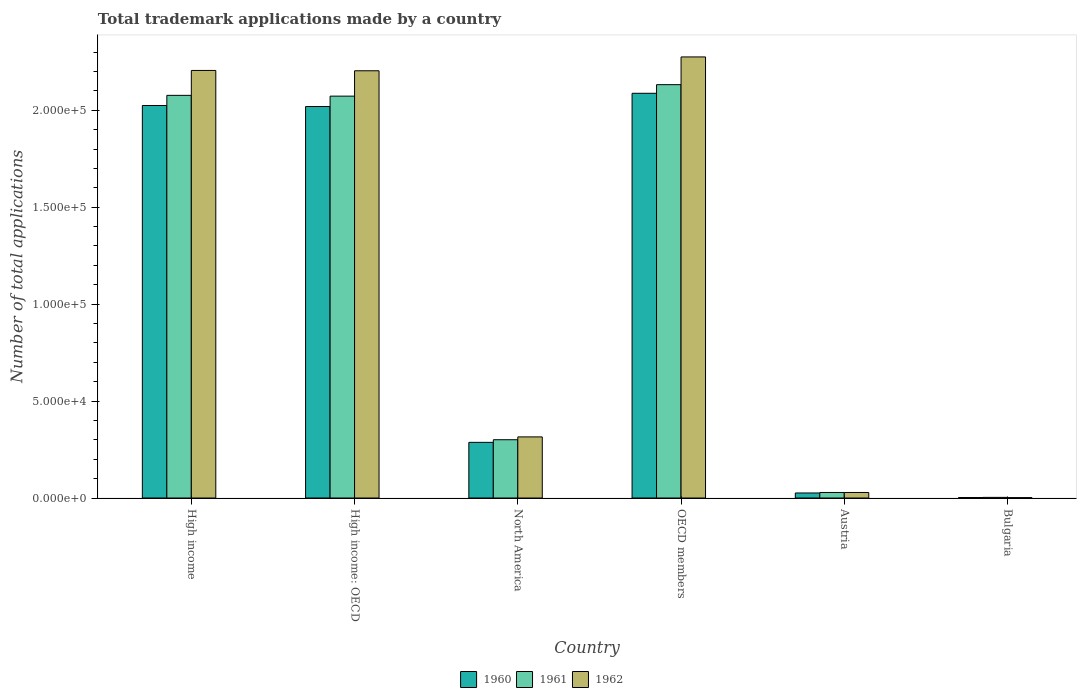How many different coloured bars are there?
Ensure brevity in your answer.  3. How many groups of bars are there?
Your answer should be very brief. 6. Are the number of bars per tick equal to the number of legend labels?
Give a very brief answer. Yes. Are the number of bars on each tick of the X-axis equal?
Your response must be concise. Yes. How many bars are there on the 5th tick from the right?
Provide a short and direct response. 3. What is the label of the 4th group of bars from the left?
Provide a short and direct response. OECD members. In how many cases, is the number of bars for a given country not equal to the number of legend labels?
Keep it short and to the point. 0. What is the number of applications made by in 1960 in OECD members?
Provide a short and direct response. 2.09e+05. Across all countries, what is the maximum number of applications made by in 1961?
Your answer should be compact. 2.13e+05. Across all countries, what is the minimum number of applications made by in 1962?
Provide a succinct answer. 195. In which country was the number of applications made by in 1961 maximum?
Offer a very short reply. OECD members. In which country was the number of applications made by in 1961 minimum?
Provide a succinct answer. Bulgaria. What is the total number of applications made by in 1960 in the graph?
Offer a terse response. 6.45e+05. What is the difference between the number of applications made by in 1962 in High income and that in High income: OECD?
Your answer should be very brief. 170. What is the difference between the number of applications made by in 1962 in Austria and the number of applications made by in 1961 in High income?
Your answer should be very brief. -2.05e+05. What is the average number of applications made by in 1962 per country?
Provide a short and direct response. 1.17e+05. What is the difference between the number of applications made by of/in 1962 and number of applications made by of/in 1961 in Austria?
Provide a succinct answer. -3. In how many countries, is the number of applications made by in 1960 greater than 200000?
Your answer should be very brief. 3. What is the ratio of the number of applications made by in 1960 in High income: OECD to that in OECD members?
Provide a short and direct response. 0.97. Is the number of applications made by in 1960 in High income less than that in North America?
Provide a short and direct response. No. Is the difference between the number of applications made by in 1962 in High income and North America greater than the difference between the number of applications made by in 1961 in High income and North America?
Keep it short and to the point. Yes. What is the difference between the highest and the second highest number of applications made by in 1961?
Offer a terse response. -401. What is the difference between the highest and the lowest number of applications made by in 1960?
Offer a very short reply. 2.09e+05. In how many countries, is the number of applications made by in 1960 greater than the average number of applications made by in 1960 taken over all countries?
Give a very brief answer. 3. Is the sum of the number of applications made by in 1962 in Bulgaria and High income greater than the maximum number of applications made by in 1960 across all countries?
Ensure brevity in your answer.  Yes. Is it the case that in every country, the sum of the number of applications made by in 1962 and number of applications made by in 1960 is greater than the number of applications made by in 1961?
Make the answer very short. Yes. How many bars are there?
Your answer should be compact. 18. Are all the bars in the graph horizontal?
Offer a terse response. No. What is the difference between two consecutive major ticks on the Y-axis?
Make the answer very short. 5.00e+04. Are the values on the major ticks of Y-axis written in scientific E-notation?
Give a very brief answer. Yes. Does the graph contain grids?
Provide a short and direct response. No. How are the legend labels stacked?
Your response must be concise. Horizontal. What is the title of the graph?
Offer a very short reply. Total trademark applications made by a country. What is the label or title of the Y-axis?
Give a very brief answer. Number of total applications. What is the Number of total applications in 1960 in High income?
Offer a very short reply. 2.02e+05. What is the Number of total applications in 1961 in High income?
Your answer should be very brief. 2.08e+05. What is the Number of total applications in 1962 in High income?
Provide a short and direct response. 2.21e+05. What is the Number of total applications of 1960 in High income: OECD?
Your answer should be very brief. 2.02e+05. What is the Number of total applications of 1961 in High income: OECD?
Offer a very short reply. 2.07e+05. What is the Number of total applications of 1962 in High income: OECD?
Ensure brevity in your answer.  2.20e+05. What is the Number of total applications in 1960 in North America?
Your answer should be very brief. 2.87e+04. What is the Number of total applications of 1961 in North America?
Provide a succinct answer. 3.01e+04. What is the Number of total applications in 1962 in North America?
Offer a very short reply. 3.15e+04. What is the Number of total applications in 1960 in OECD members?
Your answer should be very brief. 2.09e+05. What is the Number of total applications in 1961 in OECD members?
Give a very brief answer. 2.13e+05. What is the Number of total applications of 1962 in OECD members?
Your response must be concise. 2.28e+05. What is the Number of total applications in 1960 in Austria?
Your answer should be very brief. 2596. What is the Number of total applications of 1961 in Austria?
Provide a short and direct response. 2852. What is the Number of total applications of 1962 in Austria?
Make the answer very short. 2849. What is the Number of total applications of 1960 in Bulgaria?
Make the answer very short. 250. What is the Number of total applications in 1961 in Bulgaria?
Provide a short and direct response. 318. What is the Number of total applications in 1962 in Bulgaria?
Provide a short and direct response. 195. Across all countries, what is the maximum Number of total applications of 1960?
Your response must be concise. 2.09e+05. Across all countries, what is the maximum Number of total applications in 1961?
Your response must be concise. 2.13e+05. Across all countries, what is the maximum Number of total applications in 1962?
Give a very brief answer. 2.28e+05. Across all countries, what is the minimum Number of total applications in 1960?
Ensure brevity in your answer.  250. Across all countries, what is the minimum Number of total applications of 1961?
Your answer should be compact. 318. Across all countries, what is the minimum Number of total applications of 1962?
Make the answer very short. 195. What is the total Number of total applications in 1960 in the graph?
Your response must be concise. 6.45e+05. What is the total Number of total applications in 1961 in the graph?
Your answer should be very brief. 6.61e+05. What is the total Number of total applications in 1962 in the graph?
Provide a short and direct response. 7.03e+05. What is the difference between the Number of total applications in 1960 in High income and that in High income: OECD?
Provide a short and direct response. 540. What is the difference between the Number of total applications in 1961 in High income and that in High income: OECD?
Your answer should be compact. 401. What is the difference between the Number of total applications of 1962 in High income and that in High income: OECD?
Provide a succinct answer. 170. What is the difference between the Number of total applications in 1960 in High income and that in North America?
Ensure brevity in your answer.  1.74e+05. What is the difference between the Number of total applications in 1961 in High income and that in North America?
Give a very brief answer. 1.78e+05. What is the difference between the Number of total applications of 1962 in High income and that in North America?
Your response must be concise. 1.89e+05. What is the difference between the Number of total applications in 1960 in High income and that in OECD members?
Ensure brevity in your answer.  -6293. What is the difference between the Number of total applications of 1961 in High income and that in OECD members?
Your answer should be compact. -5516. What is the difference between the Number of total applications of 1962 in High income and that in OECD members?
Your answer should be compact. -6969. What is the difference between the Number of total applications of 1960 in High income and that in Austria?
Offer a very short reply. 2.00e+05. What is the difference between the Number of total applications of 1961 in High income and that in Austria?
Provide a short and direct response. 2.05e+05. What is the difference between the Number of total applications in 1962 in High income and that in Austria?
Make the answer very short. 2.18e+05. What is the difference between the Number of total applications of 1960 in High income and that in Bulgaria?
Offer a terse response. 2.02e+05. What is the difference between the Number of total applications of 1961 in High income and that in Bulgaria?
Provide a succinct answer. 2.07e+05. What is the difference between the Number of total applications of 1962 in High income and that in Bulgaria?
Make the answer very short. 2.20e+05. What is the difference between the Number of total applications of 1960 in High income: OECD and that in North America?
Your response must be concise. 1.73e+05. What is the difference between the Number of total applications of 1961 in High income: OECD and that in North America?
Your answer should be very brief. 1.77e+05. What is the difference between the Number of total applications in 1962 in High income: OECD and that in North America?
Provide a succinct answer. 1.89e+05. What is the difference between the Number of total applications of 1960 in High income: OECD and that in OECD members?
Offer a very short reply. -6833. What is the difference between the Number of total applications in 1961 in High income: OECD and that in OECD members?
Your answer should be compact. -5917. What is the difference between the Number of total applications of 1962 in High income: OECD and that in OECD members?
Your response must be concise. -7139. What is the difference between the Number of total applications in 1960 in High income: OECD and that in Austria?
Your answer should be compact. 1.99e+05. What is the difference between the Number of total applications of 1961 in High income: OECD and that in Austria?
Keep it short and to the point. 2.04e+05. What is the difference between the Number of total applications of 1962 in High income: OECD and that in Austria?
Your answer should be compact. 2.18e+05. What is the difference between the Number of total applications in 1960 in High income: OECD and that in Bulgaria?
Provide a short and direct response. 2.02e+05. What is the difference between the Number of total applications in 1961 in High income: OECD and that in Bulgaria?
Ensure brevity in your answer.  2.07e+05. What is the difference between the Number of total applications of 1962 in High income: OECD and that in Bulgaria?
Your answer should be compact. 2.20e+05. What is the difference between the Number of total applications of 1960 in North America and that in OECD members?
Make the answer very short. -1.80e+05. What is the difference between the Number of total applications of 1961 in North America and that in OECD members?
Provide a succinct answer. -1.83e+05. What is the difference between the Number of total applications of 1962 in North America and that in OECD members?
Keep it short and to the point. -1.96e+05. What is the difference between the Number of total applications of 1960 in North America and that in Austria?
Your answer should be compact. 2.61e+04. What is the difference between the Number of total applications in 1961 in North America and that in Austria?
Offer a very short reply. 2.72e+04. What is the difference between the Number of total applications of 1962 in North America and that in Austria?
Your answer should be compact. 2.87e+04. What is the difference between the Number of total applications in 1960 in North America and that in Bulgaria?
Offer a very short reply. 2.85e+04. What is the difference between the Number of total applications of 1961 in North America and that in Bulgaria?
Your response must be concise. 2.97e+04. What is the difference between the Number of total applications in 1962 in North America and that in Bulgaria?
Provide a succinct answer. 3.13e+04. What is the difference between the Number of total applications of 1960 in OECD members and that in Austria?
Offer a very short reply. 2.06e+05. What is the difference between the Number of total applications of 1961 in OECD members and that in Austria?
Your answer should be very brief. 2.10e+05. What is the difference between the Number of total applications in 1962 in OECD members and that in Austria?
Offer a very short reply. 2.25e+05. What is the difference between the Number of total applications of 1960 in OECD members and that in Bulgaria?
Offer a terse response. 2.09e+05. What is the difference between the Number of total applications in 1961 in OECD members and that in Bulgaria?
Keep it short and to the point. 2.13e+05. What is the difference between the Number of total applications in 1962 in OECD members and that in Bulgaria?
Give a very brief answer. 2.27e+05. What is the difference between the Number of total applications of 1960 in Austria and that in Bulgaria?
Offer a very short reply. 2346. What is the difference between the Number of total applications in 1961 in Austria and that in Bulgaria?
Offer a terse response. 2534. What is the difference between the Number of total applications in 1962 in Austria and that in Bulgaria?
Keep it short and to the point. 2654. What is the difference between the Number of total applications in 1960 in High income and the Number of total applications in 1961 in High income: OECD?
Your answer should be compact. -4828. What is the difference between the Number of total applications of 1960 in High income and the Number of total applications of 1962 in High income: OECD?
Your answer should be compact. -1.79e+04. What is the difference between the Number of total applications of 1961 in High income and the Number of total applications of 1962 in High income: OECD?
Your response must be concise. -1.27e+04. What is the difference between the Number of total applications of 1960 in High income and the Number of total applications of 1961 in North America?
Provide a succinct answer. 1.72e+05. What is the difference between the Number of total applications in 1960 in High income and the Number of total applications in 1962 in North America?
Offer a terse response. 1.71e+05. What is the difference between the Number of total applications of 1961 in High income and the Number of total applications of 1962 in North America?
Give a very brief answer. 1.76e+05. What is the difference between the Number of total applications of 1960 in High income and the Number of total applications of 1961 in OECD members?
Offer a very short reply. -1.07e+04. What is the difference between the Number of total applications in 1960 in High income and the Number of total applications in 1962 in OECD members?
Ensure brevity in your answer.  -2.51e+04. What is the difference between the Number of total applications in 1961 in High income and the Number of total applications in 1962 in OECD members?
Your response must be concise. -1.98e+04. What is the difference between the Number of total applications of 1960 in High income and the Number of total applications of 1961 in Austria?
Make the answer very short. 2.00e+05. What is the difference between the Number of total applications of 1960 in High income and the Number of total applications of 1962 in Austria?
Provide a succinct answer. 2.00e+05. What is the difference between the Number of total applications in 1961 in High income and the Number of total applications in 1962 in Austria?
Provide a succinct answer. 2.05e+05. What is the difference between the Number of total applications in 1960 in High income and the Number of total applications in 1961 in Bulgaria?
Give a very brief answer. 2.02e+05. What is the difference between the Number of total applications of 1960 in High income and the Number of total applications of 1962 in Bulgaria?
Offer a very short reply. 2.02e+05. What is the difference between the Number of total applications of 1961 in High income and the Number of total applications of 1962 in Bulgaria?
Give a very brief answer. 2.08e+05. What is the difference between the Number of total applications of 1960 in High income: OECD and the Number of total applications of 1961 in North America?
Your answer should be compact. 1.72e+05. What is the difference between the Number of total applications in 1960 in High income: OECD and the Number of total applications in 1962 in North America?
Offer a very short reply. 1.70e+05. What is the difference between the Number of total applications in 1961 in High income: OECD and the Number of total applications in 1962 in North America?
Provide a succinct answer. 1.76e+05. What is the difference between the Number of total applications of 1960 in High income: OECD and the Number of total applications of 1961 in OECD members?
Give a very brief answer. -1.13e+04. What is the difference between the Number of total applications of 1960 in High income: OECD and the Number of total applications of 1962 in OECD members?
Your answer should be compact. -2.56e+04. What is the difference between the Number of total applications in 1961 in High income: OECD and the Number of total applications in 1962 in OECD members?
Provide a succinct answer. -2.02e+04. What is the difference between the Number of total applications in 1960 in High income: OECD and the Number of total applications in 1961 in Austria?
Keep it short and to the point. 1.99e+05. What is the difference between the Number of total applications of 1960 in High income: OECD and the Number of total applications of 1962 in Austria?
Your answer should be compact. 1.99e+05. What is the difference between the Number of total applications in 1961 in High income: OECD and the Number of total applications in 1962 in Austria?
Your answer should be very brief. 2.04e+05. What is the difference between the Number of total applications in 1960 in High income: OECD and the Number of total applications in 1961 in Bulgaria?
Ensure brevity in your answer.  2.02e+05. What is the difference between the Number of total applications in 1960 in High income: OECD and the Number of total applications in 1962 in Bulgaria?
Provide a short and direct response. 2.02e+05. What is the difference between the Number of total applications of 1961 in High income: OECD and the Number of total applications of 1962 in Bulgaria?
Your answer should be compact. 2.07e+05. What is the difference between the Number of total applications of 1960 in North America and the Number of total applications of 1961 in OECD members?
Your response must be concise. -1.85e+05. What is the difference between the Number of total applications of 1960 in North America and the Number of total applications of 1962 in OECD members?
Ensure brevity in your answer.  -1.99e+05. What is the difference between the Number of total applications of 1961 in North America and the Number of total applications of 1962 in OECD members?
Offer a terse response. -1.97e+05. What is the difference between the Number of total applications of 1960 in North America and the Number of total applications of 1961 in Austria?
Provide a succinct answer. 2.59e+04. What is the difference between the Number of total applications in 1960 in North America and the Number of total applications in 1962 in Austria?
Ensure brevity in your answer.  2.59e+04. What is the difference between the Number of total applications in 1961 in North America and the Number of total applications in 1962 in Austria?
Your answer should be very brief. 2.72e+04. What is the difference between the Number of total applications of 1960 in North America and the Number of total applications of 1961 in Bulgaria?
Your response must be concise. 2.84e+04. What is the difference between the Number of total applications of 1960 in North America and the Number of total applications of 1962 in Bulgaria?
Provide a succinct answer. 2.85e+04. What is the difference between the Number of total applications of 1961 in North America and the Number of total applications of 1962 in Bulgaria?
Provide a short and direct response. 2.99e+04. What is the difference between the Number of total applications of 1960 in OECD members and the Number of total applications of 1961 in Austria?
Make the answer very short. 2.06e+05. What is the difference between the Number of total applications in 1960 in OECD members and the Number of total applications in 1962 in Austria?
Your answer should be very brief. 2.06e+05. What is the difference between the Number of total applications of 1961 in OECD members and the Number of total applications of 1962 in Austria?
Provide a short and direct response. 2.10e+05. What is the difference between the Number of total applications of 1960 in OECD members and the Number of total applications of 1961 in Bulgaria?
Ensure brevity in your answer.  2.08e+05. What is the difference between the Number of total applications of 1960 in OECD members and the Number of total applications of 1962 in Bulgaria?
Ensure brevity in your answer.  2.09e+05. What is the difference between the Number of total applications in 1961 in OECD members and the Number of total applications in 1962 in Bulgaria?
Ensure brevity in your answer.  2.13e+05. What is the difference between the Number of total applications of 1960 in Austria and the Number of total applications of 1961 in Bulgaria?
Provide a succinct answer. 2278. What is the difference between the Number of total applications of 1960 in Austria and the Number of total applications of 1962 in Bulgaria?
Your answer should be very brief. 2401. What is the difference between the Number of total applications of 1961 in Austria and the Number of total applications of 1962 in Bulgaria?
Make the answer very short. 2657. What is the average Number of total applications in 1960 per country?
Ensure brevity in your answer.  1.07e+05. What is the average Number of total applications in 1961 per country?
Give a very brief answer. 1.10e+05. What is the average Number of total applications of 1962 per country?
Provide a succinct answer. 1.17e+05. What is the difference between the Number of total applications of 1960 and Number of total applications of 1961 in High income?
Offer a very short reply. -5229. What is the difference between the Number of total applications in 1960 and Number of total applications in 1962 in High income?
Give a very brief answer. -1.81e+04. What is the difference between the Number of total applications in 1961 and Number of total applications in 1962 in High income?
Keep it short and to the point. -1.29e+04. What is the difference between the Number of total applications in 1960 and Number of total applications in 1961 in High income: OECD?
Offer a very short reply. -5368. What is the difference between the Number of total applications in 1960 and Number of total applications in 1962 in High income: OECD?
Ensure brevity in your answer.  -1.85e+04. What is the difference between the Number of total applications in 1961 and Number of total applications in 1962 in High income: OECD?
Your response must be concise. -1.31e+04. What is the difference between the Number of total applications in 1960 and Number of total applications in 1961 in North America?
Keep it short and to the point. -1355. What is the difference between the Number of total applications in 1960 and Number of total applications in 1962 in North America?
Your response must be concise. -2817. What is the difference between the Number of total applications of 1961 and Number of total applications of 1962 in North America?
Offer a terse response. -1462. What is the difference between the Number of total applications of 1960 and Number of total applications of 1961 in OECD members?
Ensure brevity in your answer.  -4452. What is the difference between the Number of total applications in 1960 and Number of total applications in 1962 in OECD members?
Offer a very short reply. -1.88e+04. What is the difference between the Number of total applications of 1961 and Number of total applications of 1962 in OECD members?
Provide a succinct answer. -1.43e+04. What is the difference between the Number of total applications in 1960 and Number of total applications in 1961 in Austria?
Provide a short and direct response. -256. What is the difference between the Number of total applications of 1960 and Number of total applications of 1962 in Austria?
Ensure brevity in your answer.  -253. What is the difference between the Number of total applications of 1960 and Number of total applications of 1961 in Bulgaria?
Make the answer very short. -68. What is the difference between the Number of total applications in 1961 and Number of total applications in 1962 in Bulgaria?
Make the answer very short. 123. What is the ratio of the Number of total applications of 1960 in High income to that in High income: OECD?
Keep it short and to the point. 1. What is the ratio of the Number of total applications of 1960 in High income to that in North America?
Offer a very short reply. 7.05. What is the ratio of the Number of total applications of 1961 in High income to that in North America?
Your answer should be compact. 6.91. What is the ratio of the Number of total applications in 1962 in High income to that in North America?
Ensure brevity in your answer.  7. What is the ratio of the Number of total applications of 1960 in High income to that in OECD members?
Make the answer very short. 0.97. What is the ratio of the Number of total applications in 1961 in High income to that in OECD members?
Provide a short and direct response. 0.97. What is the ratio of the Number of total applications of 1962 in High income to that in OECD members?
Your answer should be compact. 0.97. What is the ratio of the Number of total applications in 1960 in High income to that in Austria?
Ensure brevity in your answer.  78. What is the ratio of the Number of total applications of 1961 in High income to that in Austria?
Keep it short and to the point. 72.83. What is the ratio of the Number of total applications in 1962 in High income to that in Austria?
Your answer should be compact. 77.42. What is the ratio of the Number of total applications in 1960 in High income to that in Bulgaria?
Offer a terse response. 809.91. What is the ratio of the Number of total applications of 1961 in High income to that in Bulgaria?
Ensure brevity in your answer.  653.16. What is the ratio of the Number of total applications of 1962 in High income to that in Bulgaria?
Your answer should be very brief. 1131.08. What is the ratio of the Number of total applications in 1960 in High income: OECD to that in North America?
Offer a very short reply. 7.03. What is the ratio of the Number of total applications in 1961 in High income: OECD to that in North America?
Offer a very short reply. 6.9. What is the ratio of the Number of total applications in 1962 in High income: OECD to that in North America?
Make the answer very short. 6.99. What is the ratio of the Number of total applications in 1960 in High income: OECD to that in OECD members?
Your answer should be very brief. 0.97. What is the ratio of the Number of total applications of 1961 in High income: OECD to that in OECD members?
Your answer should be very brief. 0.97. What is the ratio of the Number of total applications of 1962 in High income: OECD to that in OECD members?
Your response must be concise. 0.97. What is the ratio of the Number of total applications in 1960 in High income: OECD to that in Austria?
Offer a terse response. 77.79. What is the ratio of the Number of total applications in 1961 in High income: OECD to that in Austria?
Your response must be concise. 72.69. What is the ratio of the Number of total applications in 1962 in High income: OECD to that in Austria?
Make the answer very short. 77.36. What is the ratio of the Number of total applications of 1960 in High income: OECD to that in Bulgaria?
Keep it short and to the point. 807.75. What is the ratio of the Number of total applications in 1961 in High income: OECD to that in Bulgaria?
Offer a terse response. 651.9. What is the ratio of the Number of total applications of 1962 in High income: OECD to that in Bulgaria?
Provide a succinct answer. 1130.21. What is the ratio of the Number of total applications in 1960 in North America to that in OECD members?
Provide a short and direct response. 0.14. What is the ratio of the Number of total applications of 1961 in North America to that in OECD members?
Make the answer very short. 0.14. What is the ratio of the Number of total applications in 1962 in North America to that in OECD members?
Your answer should be very brief. 0.14. What is the ratio of the Number of total applications in 1960 in North America to that in Austria?
Offer a very short reply. 11.06. What is the ratio of the Number of total applications in 1961 in North America to that in Austria?
Provide a short and direct response. 10.54. What is the ratio of the Number of total applications of 1962 in North America to that in Austria?
Offer a terse response. 11.07. What is the ratio of the Number of total applications of 1960 in North America to that in Bulgaria?
Give a very brief answer. 114.83. What is the ratio of the Number of total applications of 1961 in North America to that in Bulgaria?
Offer a terse response. 94.54. What is the ratio of the Number of total applications in 1962 in North America to that in Bulgaria?
Your answer should be compact. 161.67. What is the ratio of the Number of total applications of 1960 in OECD members to that in Austria?
Offer a terse response. 80.42. What is the ratio of the Number of total applications of 1961 in OECD members to that in Austria?
Your answer should be very brief. 74.76. What is the ratio of the Number of total applications in 1962 in OECD members to that in Austria?
Your answer should be compact. 79.86. What is the ratio of the Number of total applications in 1960 in OECD members to that in Bulgaria?
Provide a succinct answer. 835.08. What is the ratio of the Number of total applications in 1961 in OECD members to that in Bulgaria?
Your response must be concise. 670.51. What is the ratio of the Number of total applications in 1962 in OECD members to that in Bulgaria?
Give a very brief answer. 1166.82. What is the ratio of the Number of total applications of 1960 in Austria to that in Bulgaria?
Keep it short and to the point. 10.38. What is the ratio of the Number of total applications of 1961 in Austria to that in Bulgaria?
Your answer should be compact. 8.97. What is the ratio of the Number of total applications of 1962 in Austria to that in Bulgaria?
Provide a short and direct response. 14.61. What is the difference between the highest and the second highest Number of total applications in 1960?
Your answer should be compact. 6293. What is the difference between the highest and the second highest Number of total applications in 1961?
Offer a terse response. 5516. What is the difference between the highest and the second highest Number of total applications of 1962?
Offer a very short reply. 6969. What is the difference between the highest and the lowest Number of total applications in 1960?
Offer a terse response. 2.09e+05. What is the difference between the highest and the lowest Number of total applications in 1961?
Keep it short and to the point. 2.13e+05. What is the difference between the highest and the lowest Number of total applications in 1962?
Your answer should be compact. 2.27e+05. 